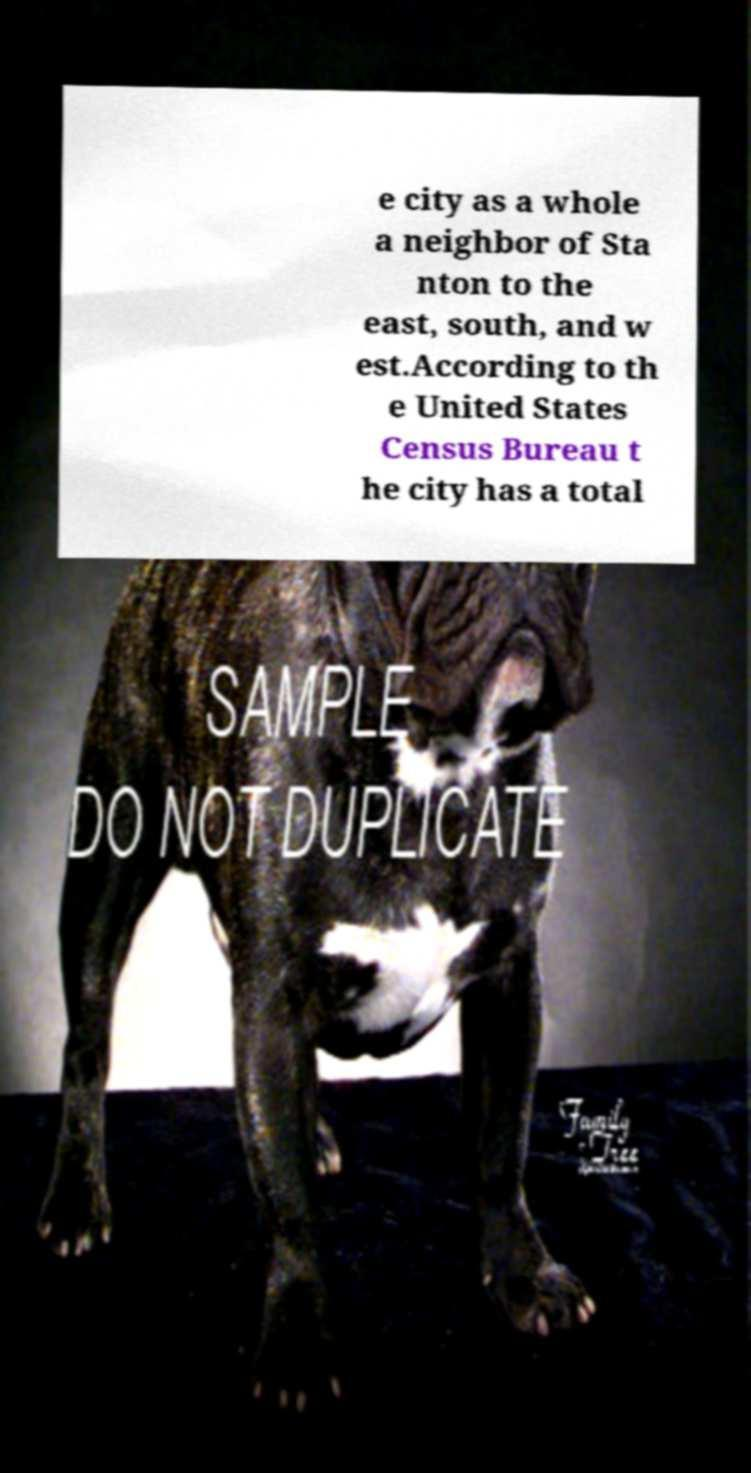Could you assist in decoding the text presented in this image and type it out clearly? e city as a whole a neighbor of Sta nton to the east, south, and w est.According to th e United States Census Bureau t he city has a total 